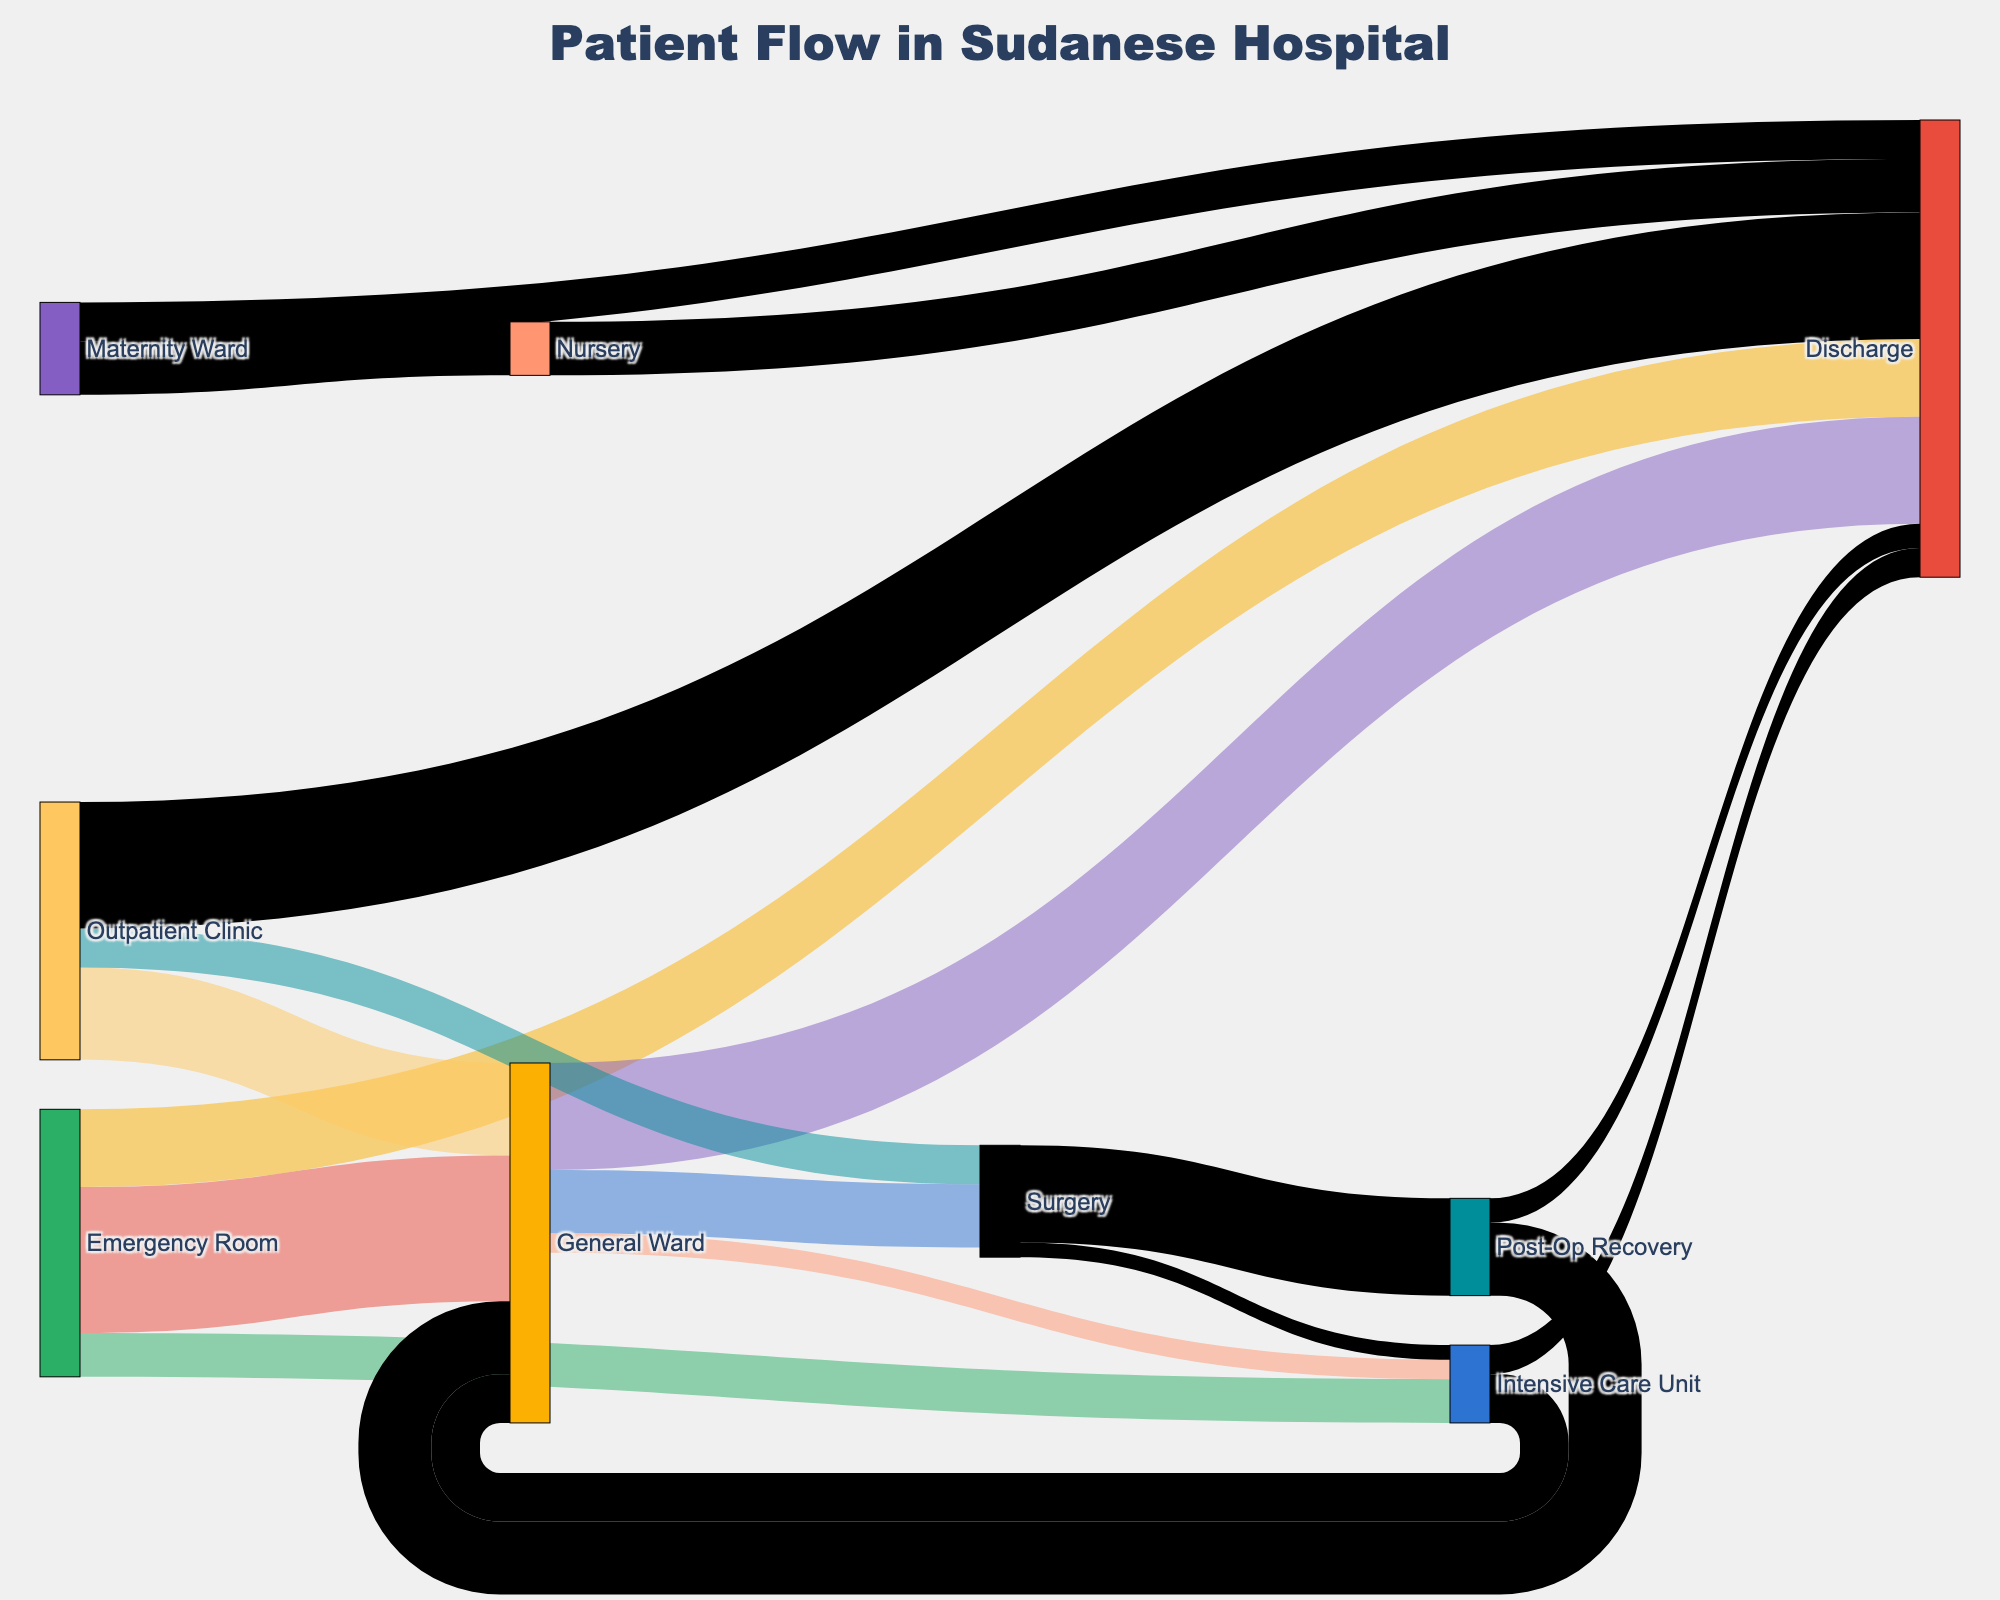What's the title of the figure? The title of the figure is usually placed at the top of the chart. In this case, the rendered figure title is "Patient Flow in Sudanese Hospital".
Answer: Patient Flow in Sudanese Hospital What departments receive patients directly from the Emergency Room? To find this, look at the flows starting from the Emergency Room and trace them to their destinations. The Emergency Room sends patients to the General Ward, Intensive Care Unit, and Discharge.
Answer: General Ward, Intensive Care Unit, Discharge What pathway has the highest patient flow from the General Ward? To answer this, examine the links coming out of the General Ward and compare their values. The pathways are General Ward to Surgery (65), General Ward to Discharge (110), and General Ward to Intensive Care Unit (20). The highest patient flow is from General Ward to Discharge.
Answer: General Ward to Discharge How many patients flow from the Outpatient Clinic to Surgery? Identify the connection between the Outpatient Clinic and Surgery and check the value of the flow. According to the data, 40 patients move from the Outpatient Clinic to Surgery.
Answer: 40 Which department sends the most patients to the General Ward? Look at the flows that end at the General Ward and compare their values: Emergency Room (150), Outpatient Clinic (95), Post-Op Recovery (75), and Intensive Care Unit (50). The Emergency Room sends the most patients to the General Ward.
Answer: Emergency Room What is the total number of patients discharged from all departments combined? Sum the patients discharged from each department: Emergency Room (80), General Ward (110), Outpatient Clinic (130), Post-Op Recovery (25), Intensive Care Unit (30), Maternity Ward (40), Nursery (55). The total is 470 patients.
Answer: 470 Which pathway has the lowest number of patients flowing into the Intensive Care Unit? Look for pathways that end in the Intensive Care Unit and compare their values: Emergency Room (45), General Ward (20), Surgery (15). The lowest is the pathway from Surgery to Intensive Care Unit.
Answer: Surgery to Intensive Care Unit How many departments are there in total? Count all the unique departments listed as nodes in the diagram. These departments are: Emergency Room, General Ward, Intensive Care Unit, Discharge, Outpatient Clinic, Surgery, Post-Op Recovery, Maternity Ward, and Nursery, totaling 9 departments.
Answer: 9 